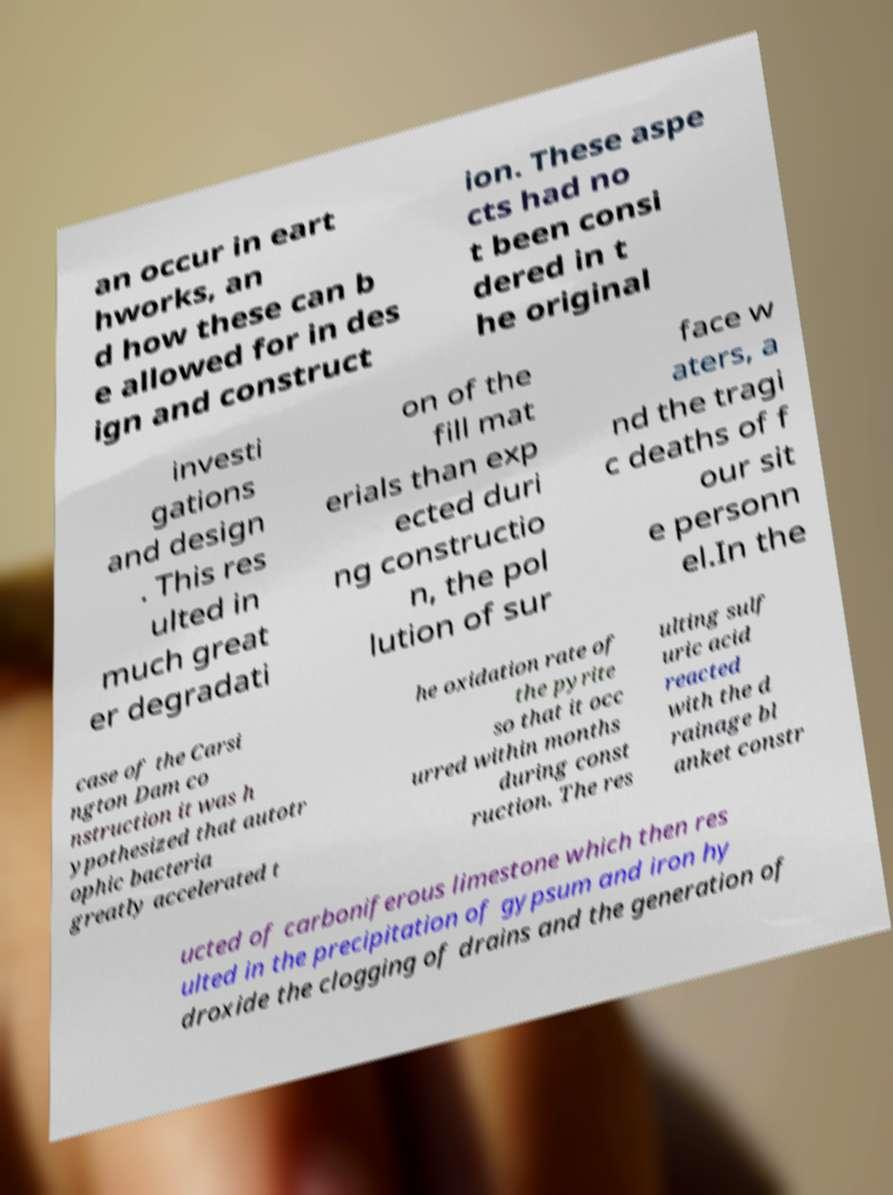Please identify and transcribe the text found in this image. an occur in eart hworks, an d how these can b e allowed for in des ign and construct ion. These aspe cts had no t been consi dered in t he original investi gations and design . This res ulted in much great er degradati on of the fill mat erials than exp ected duri ng constructio n, the pol lution of sur face w aters, a nd the tragi c deaths of f our sit e personn el.In the case of the Carsi ngton Dam co nstruction it was h ypothesized that autotr ophic bacteria greatly accelerated t he oxidation rate of the pyrite so that it occ urred within months during const ruction. The res ulting sulf uric acid reacted with the d rainage bl anket constr ucted of carboniferous limestone which then res ulted in the precipitation of gypsum and iron hy droxide the clogging of drains and the generation of 